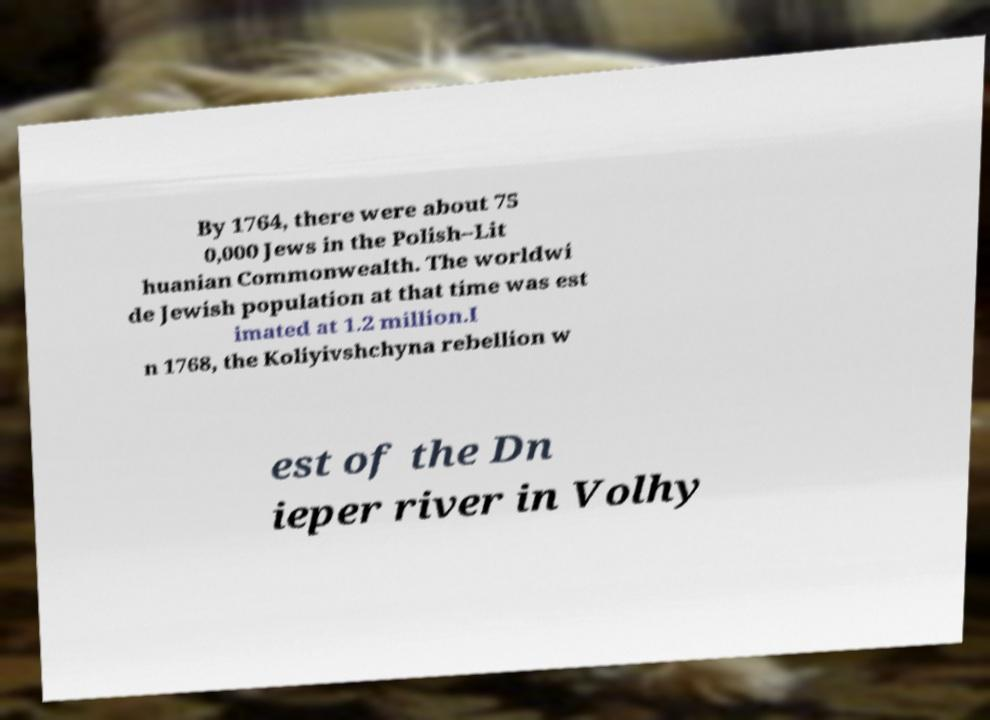Could you assist in decoding the text presented in this image and type it out clearly? By 1764, there were about 75 0,000 Jews in the Polish–Lit huanian Commonwealth. The worldwi de Jewish population at that time was est imated at 1.2 million.I n 1768, the Koliyivshchyna rebellion w est of the Dn ieper river in Volhy 